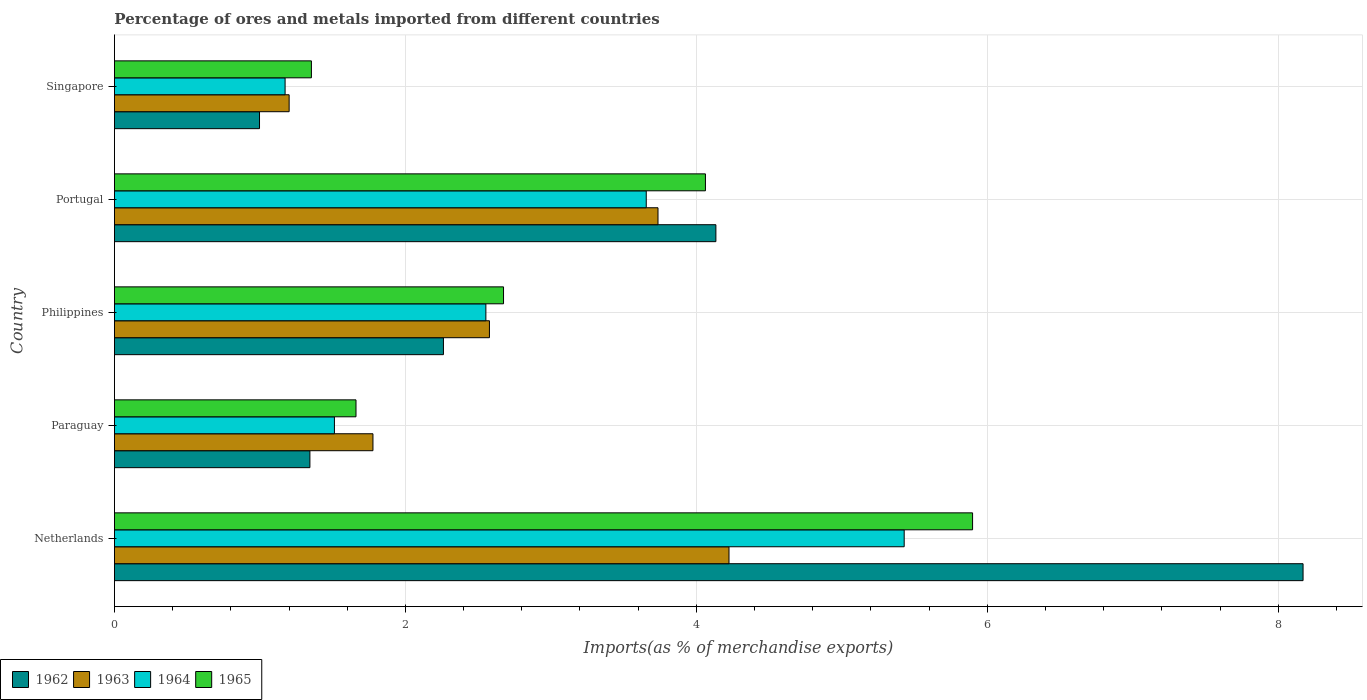How many groups of bars are there?
Your answer should be compact. 5. Are the number of bars per tick equal to the number of legend labels?
Ensure brevity in your answer.  Yes. Are the number of bars on each tick of the Y-axis equal?
Ensure brevity in your answer.  Yes. How many bars are there on the 5th tick from the bottom?
Your answer should be very brief. 4. What is the label of the 2nd group of bars from the top?
Keep it short and to the point. Portugal. In how many cases, is the number of bars for a given country not equal to the number of legend labels?
Provide a succinct answer. 0. What is the percentage of imports to different countries in 1962 in Netherlands?
Give a very brief answer. 8.17. Across all countries, what is the maximum percentage of imports to different countries in 1963?
Your response must be concise. 4.22. Across all countries, what is the minimum percentage of imports to different countries in 1964?
Your answer should be very brief. 1.17. In which country was the percentage of imports to different countries in 1962 maximum?
Offer a very short reply. Netherlands. In which country was the percentage of imports to different countries in 1965 minimum?
Offer a very short reply. Singapore. What is the total percentage of imports to different countries in 1965 in the graph?
Provide a succinct answer. 15.65. What is the difference between the percentage of imports to different countries in 1962 in Paraguay and that in Singapore?
Provide a succinct answer. 0.35. What is the difference between the percentage of imports to different countries in 1962 in Paraguay and the percentage of imports to different countries in 1964 in Philippines?
Ensure brevity in your answer.  -1.21. What is the average percentage of imports to different countries in 1965 per country?
Ensure brevity in your answer.  3.13. What is the difference between the percentage of imports to different countries in 1965 and percentage of imports to different countries in 1964 in Paraguay?
Your response must be concise. 0.15. In how many countries, is the percentage of imports to different countries in 1965 greater than 2.4 %?
Make the answer very short. 3. What is the ratio of the percentage of imports to different countries in 1964 in Paraguay to that in Singapore?
Ensure brevity in your answer.  1.29. Is the percentage of imports to different countries in 1964 in Portugal less than that in Singapore?
Offer a terse response. No. Is the difference between the percentage of imports to different countries in 1965 in Netherlands and Portugal greater than the difference between the percentage of imports to different countries in 1964 in Netherlands and Portugal?
Keep it short and to the point. Yes. What is the difference between the highest and the second highest percentage of imports to different countries in 1963?
Offer a terse response. 0.49. What is the difference between the highest and the lowest percentage of imports to different countries in 1962?
Offer a terse response. 7.17. In how many countries, is the percentage of imports to different countries in 1963 greater than the average percentage of imports to different countries in 1963 taken over all countries?
Keep it short and to the point. 2. Is it the case that in every country, the sum of the percentage of imports to different countries in 1963 and percentage of imports to different countries in 1962 is greater than the sum of percentage of imports to different countries in 1964 and percentage of imports to different countries in 1965?
Give a very brief answer. No. What does the 4th bar from the top in Philippines represents?
Your answer should be very brief. 1962. What does the 3rd bar from the bottom in Portugal represents?
Give a very brief answer. 1964. Are all the bars in the graph horizontal?
Offer a very short reply. Yes. Are the values on the major ticks of X-axis written in scientific E-notation?
Your answer should be very brief. No. How many legend labels are there?
Give a very brief answer. 4. What is the title of the graph?
Your answer should be very brief. Percentage of ores and metals imported from different countries. Does "2014" appear as one of the legend labels in the graph?
Offer a very short reply. No. What is the label or title of the X-axis?
Ensure brevity in your answer.  Imports(as % of merchandise exports). What is the Imports(as % of merchandise exports) in 1962 in Netherlands?
Give a very brief answer. 8.17. What is the Imports(as % of merchandise exports) in 1963 in Netherlands?
Your answer should be compact. 4.22. What is the Imports(as % of merchandise exports) of 1964 in Netherlands?
Provide a short and direct response. 5.43. What is the Imports(as % of merchandise exports) of 1965 in Netherlands?
Provide a short and direct response. 5.9. What is the Imports(as % of merchandise exports) in 1962 in Paraguay?
Give a very brief answer. 1.34. What is the Imports(as % of merchandise exports) of 1963 in Paraguay?
Provide a short and direct response. 1.78. What is the Imports(as % of merchandise exports) of 1964 in Paraguay?
Your response must be concise. 1.51. What is the Imports(as % of merchandise exports) in 1965 in Paraguay?
Provide a short and direct response. 1.66. What is the Imports(as % of merchandise exports) of 1962 in Philippines?
Provide a short and direct response. 2.26. What is the Imports(as % of merchandise exports) of 1963 in Philippines?
Provide a short and direct response. 2.58. What is the Imports(as % of merchandise exports) of 1964 in Philippines?
Offer a terse response. 2.55. What is the Imports(as % of merchandise exports) in 1965 in Philippines?
Make the answer very short. 2.67. What is the Imports(as % of merchandise exports) in 1962 in Portugal?
Provide a short and direct response. 4.13. What is the Imports(as % of merchandise exports) of 1963 in Portugal?
Provide a succinct answer. 3.74. What is the Imports(as % of merchandise exports) of 1964 in Portugal?
Provide a succinct answer. 3.66. What is the Imports(as % of merchandise exports) in 1965 in Portugal?
Your answer should be very brief. 4.06. What is the Imports(as % of merchandise exports) in 1962 in Singapore?
Offer a terse response. 1. What is the Imports(as % of merchandise exports) of 1963 in Singapore?
Offer a terse response. 1.2. What is the Imports(as % of merchandise exports) of 1964 in Singapore?
Ensure brevity in your answer.  1.17. What is the Imports(as % of merchandise exports) in 1965 in Singapore?
Give a very brief answer. 1.35. Across all countries, what is the maximum Imports(as % of merchandise exports) of 1962?
Keep it short and to the point. 8.17. Across all countries, what is the maximum Imports(as % of merchandise exports) of 1963?
Provide a short and direct response. 4.22. Across all countries, what is the maximum Imports(as % of merchandise exports) of 1964?
Your answer should be very brief. 5.43. Across all countries, what is the maximum Imports(as % of merchandise exports) of 1965?
Provide a succinct answer. 5.9. Across all countries, what is the minimum Imports(as % of merchandise exports) in 1962?
Provide a short and direct response. 1. Across all countries, what is the minimum Imports(as % of merchandise exports) in 1963?
Your answer should be very brief. 1.2. Across all countries, what is the minimum Imports(as % of merchandise exports) in 1964?
Your answer should be compact. 1.17. Across all countries, what is the minimum Imports(as % of merchandise exports) of 1965?
Your response must be concise. 1.35. What is the total Imports(as % of merchandise exports) of 1962 in the graph?
Ensure brevity in your answer.  16.91. What is the total Imports(as % of merchandise exports) in 1963 in the graph?
Offer a very short reply. 13.52. What is the total Imports(as % of merchandise exports) of 1964 in the graph?
Ensure brevity in your answer.  14.32. What is the total Imports(as % of merchandise exports) of 1965 in the graph?
Your answer should be compact. 15.65. What is the difference between the Imports(as % of merchandise exports) of 1962 in Netherlands and that in Paraguay?
Your answer should be very brief. 6.83. What is the difference between the Imports(as % of merchandise exports) of 1963 in Netherlands and that in Paraguay?
Keep it short and to the point. 2.45. What is the difference between the Imports(as % of merchandise exports) in 1964 in Netherlands and that in Paraguay?
Your response must be concise. 3.92. What is the difference between the Imports(as % of merchandise exports) in 1965 in Netherlands and that in Paraguay?
Offer a very short reply. 4.24. What is the difference between the Imports(as % of merchandise exports) of 1962 in Netherlands and that in Philippines?
Ensure brevity in your answer.  5.91. What is the difference between the Imports(as % of merchandise exports) in 1963 in Netherlands and that in Philippines?
Give a very brief answer. 1.65. What is the difference between the Imports(as % of merchandise exports) of 1964 in Netherlands and that in Philippines?
Provide a short and direct response. 2.88. What is the difference between the Imports(as % of merchandise exports) of 1965 in Netherlands and that in Philippines?
Keep it short and to the point. 3.22. What is the difference between the Imports(as % of merchandise exports) of 1962 in Netherlands and that in Portugal?
Offer a very short reply. 4.04. What is the difference between the Imports(as % of merchandise exports) of 1963 in Netherlands and that in Portugal?
Ensure brevity in your answer.  0.49. What is the difference between the Imports(as % of merchandise exports) of 1964 in Netherlands and that in Portugal?
Provide a succinct answer. 1.77. What is the difference between the Imports(as % of merchandise exports) of 1965 in Netherlands and that in Portugal?
Keep it short and to the point. 1.84. What is the difference between the Imports(as % of merchandise exports) in 1962 in Netherlands and that in Singapore?
Your response must be concise. 7.17. What is the difference between the Imports(as % of merchandise exports) in 1963 in Netherlands and that in Singapore?
Ensure brevity in your answer.  3.02. What is the difference between the Imports(as % of merchandise exports) in 1964 in Netherlands and that in Singapore?
Offer a very short reply. 4.26. What is the difference between the Imports(as % of merchandise exports) of 1965 in Netherlands and that in Singapore?
Your answer should be very brief. 4.55. What is the difference between the Imports(as % of merchandise exports) in 1962 in Paraguay and that in Philippines?
Provide a short and direct response. -0.92. What is the difference between the Imports(as % of merchandise exports) in 1963 in Paraguay and that in Philippines?
Your answer should be very brief. -0.8. What is the difference between the Imports(as % of merchandise exports) of 1964 in Paraguay and that in Philippines?
Give a very brief answer. -1.04. What is the difference between the Imports(as % of merchandise exports) in 1965 in Paraguay and that in Philippines?
Offer a terse response. -1.01. What is the difference between the Imports(as % of merchandise exports) in 1962 in Paraguay and that in Portugal?
Keep it short and to the point. -2.79. What is the difference between the Imports(as % of merchandise exports) of 1963 in Paraguay and that in Portugal?
Keep it short and to the point. -1.96. What is the difference between the Imports(as % of merchandise exports) of 1964 in Paraguay and that in Portugal?
Provide a short and direct response. -2.14. What is the difference between the Imports(as % of merchandise exports) of 1965 in Paraguay and that in Portugal?
Provide a succinct answer. -2.4. What is the difference between the Imports(as % of merchandise exports) of 1962 in Paraguay and that in Singapore?
Your answer should be compact. 0.35. What is the difference between the Imports(as % of merchandise exports) in 1963 in Paraguay and that in Singapore?
Your answer should be compact. 0.58. What is the difference between the Imports(as % of merchandise exports) of 1964 in Paraguay and that in Singapore?
Your response must be concise. 0.34. What is the difference between the Imports(as % of merchandise exports) in 1965 in Paraguay and that in Singapore?
Provide a succinct answer. 0.31. What is the difference between the Imports(as % of merchandise exports) of 1962 in Philippines and that in Portugal?
Keep it short and to the point. -1.87. What is the difference between the Imports(as % of merchandise exports) in 1963 in Philippines and that in Portugal?
Provide a short and direct response. -1.16. What is the difference between the Imports(as % of merchandise exports) in 1964 in Philippines and that in Portugal?
Make the answer very short. -1.1. What is the difference between the Imports(as % of merchandise exports) of 1965 in Philippines and that in Portugal?
Make the answer very short. -1.39. What is the difference between the Imports(as % of merchandise exports) of 1962 in Philippines and that in Singapore?
Keep it short and to the point. 1.26. What is the difference between the Imports(as % of merchandise exports) of 1963 in Philippines and that in Singapore?
Offer a very short reply. 1.38. What is the difference between the Imports(as % of merchandise exports) in 1964 in Philippines and that in Singapore?
Your answer should be compact. 1.38. What is the difference between the Imports(as % of merchandise exports) in 1965 in Philippines and that in Singapore?
Your answer should be very brief. 1.32. What is the difference between the Imports(as % of merchandise exports) of 1962 in Portugal and that in Singapore?
Make the answer very short. 3.14. What is the difference between the Imports(as % of merchandise exports) in 1963 in Portugal and that in Singapore?
Give a very brief answer. 2.54. What is the difference between the Imports(as % of merchandise exports) in 1964 in Portugal and that in Singapore?
Your answer should be very brief. 2.48. What is the difference between the Imports(as % of merchandise exports) of 1965 in Portugal and that in Singapore?
Your answer should be very brief. 2.71. What is the difference between the Imports(as % of merchandise exports) of 1962 in Netherlands and the Imports(as % of merchandise exports) of 1963 in Paraguay?
Ensure brevity in your answer.  6.39. What is the difference between the Imports(as % of merchandise exports) in 1962 in Netherlands and the Imports(as % of merchandise exports) in 1964 in Paraguay?
Offer a very short reply. 6.66. What is the difference between the Imports(as % of merchandise exports) of 1962 in Netherlands and the Imports(as % of merchandise exports) of 1965 in Paraguay?
Give a very brief answer. 6.51. What is the difference between the Imports(as % of merchandise exports) of 1963 in Netherlands and the Imports(as % of merchandise exports) of 1964 in Paraguay?
Ensure brevity in your answer.  2.71. What is the difference between the Imports(as % of merchandise exports) in 1963 in Netherlands and the Imports(as % of merchandise exports) in 1965 in Paraguay?
Offer a terse response. 2.56. What is the difference between the Imports(as % of merchandise exports) of 1964 in Netherlands and the Imports(as % of merchandise exports) of 1965 in Paraguay?
Offer a very short reply. 3.77. What is the difference between the Imports(as % of merchandise exports) in 1962 in Netherlands and the Imports(as % of merchandise exports) in 1963 in Philippines?
Ensure brevity in your answer.  5.59. What is the difference between the Imports(as % of merchandise exports) in 1962 in Netherlands and the Imports(as % of merchandise exports) in 1964 in Philippines?
Offer a very short reply. 5.62. What is the difference between the Imports(as % of merchandise exports) in 1962 in Netherlands and the Imports(as % of merchandise exports) in 1965 in Philippines?
Offer a very short reply. 5.5. What is the difference between the Imports(as % of merchandise exports) in 1963 in Netherlands and the Imports(as % of merchandise exports) in 1964 in Philippines?
Offer a very short reply. 1.67. What is the difference between the Imports(as % of merchandise exports) of 1963 in Netherlands and the Imports(as % of merchandise exports) of 1965 in Philippines?
Offer a very short reply. 1.55. What is the difference between the Imports(as % of merchandise exports) of 1964 in Netherlands and the Imports(as % of merchandise exports) of 1965 in Philippines?
Your answer should be compact. 2.75. What is the difference between the Imports(as % of merchandise exports) of 1962 in Netherlands and the Imports(as % of merchandise exports) of 1963 in Portugal?
Your answer should be compact. 4.43. What is the difference between the Imports(as % of merchandise exports) of 1962 in Netherlands and the Imports(as % of merchandise exports) of 1964 in Portugal?
Ensure brevity in your answer.  4.51. What is the difference between the Imports(as % of merchandise exports) in 1962 in Netherlands and the Imports(as % of merchandise exports) in 1965 in Portugal?
Your answer should be very brief. 4.11. What is the difference between the Imports(as % of merchandise exports) of 1963 in Netherlands and the Imports(as % of merchandise exports) of 1964 in Portugal?
Provide a short and direct response. 0.57. What is the difference between the Imports(as % of merchandise exports) in 1963 in Netherlands and the Imports(as % of merchandise exports) in 1965 in Portugal?
Provide a succinct answer. 0.16. What is the difference between the Imports(as % of merchandise exports) of 1964 in Netherlands and the Imports(as % of merchandise exports) of 1965 in Portugal?
Your response must be concise. 1.37. What is the difference between the Imports(as % of merchandise exports) in 1962 in Netherlands and the Imports(as % of merchandise exports) in 1963 in Singapore?
Ensure brevity in your answer.  6.97. What is the difference between the Imports(as % of merchandise exports) of 1962 in Netherlands and the Imports(as % of merchandise exports) of 1964 in Singapore?
Your answer should be very brief. 7. What is the difference between the Imports(as % of merchandise exports) of 1962 in Netherlands and the Imports(as % of merchandise exports) of 1965 in Singapore?
Your answer should be compact. 6.82. What is the difference between the Imports(as % of merchandise exports) in 1963 in Netherlands and the Imports(as % of merchandise exports) in 1964 in Singapore?
Your answer should be compact. 3.05. What is the difference between the Imports(as % of merchandise exports) in 1963 in Netherlands and the Imports(as % of merchandise exports) in 1965 in Singapore?
Provide a short and direct response. 2.87. What is the difference between the Imports(as % of merchandise exports) of 1964 in Netherlands and the Imports(as % of merchandise exports) of 1965 in Singapore?
Your response must be concise. 4.07. What is the difference between the Imports(as % of merchandise exports) in 1962 in Paraguay and the Imports(as % of merchandise exports) in 1963 in Philippines?
Offer a very short reply. -1.23. What is the difference between the Imports(as % of merchandise exports) of 1962 in Paraguay and the Imports(as % of merchandise exports) of 1964 in Philippines?
Offer a terse response. -1.21. What is the difference between the Imports(as % of merchandise exports) in 1962 in Paraguay and the Imports(as % of merchandise exports) in 1965 in Philippines?
Offer a very short reply. -1.33. What is the difference between the Imports(as % of merchandise exports) in 1963 in Paraguay and the Imports(as % of merchandise exports) in 1964 in Philippines?
Offer a terse response. -0.78. What is the difference between the Imports(as % of merchandise exports) in 1963 in Paraguay and the Imports(as % of merchandise exports) in 1965 in Philippines?
Your answer should be compact. -0.9. What is the difference between the Imports(as % of merchandise exports) in 1964 in Paraguay and the Imports(as % of merchandise exports) in 1965 in Philippines?
Keep it short and to the point. -1.16. What is the difference between the Imports(as % of merchandise exports) in 1962 in Paraguay and the Imports(as % of merchandise exports) in 1963 in Portugal?
Keep it short and to the point. -2.39. What is the difference between the Imports(as % of merchandise exports) of 1962 in Paraguay and the Imports(as % of merchandise exports) of 1964 in Portugal?
Give a very brief answer. -2.31. What is the difference between the Imports(as % of merchandise exports) of 1962 in Paraguay and the Imports(as % of merchandise exports) of 1965 in Portugal?
Offer a terse response. -2.72. What is the difference between the Imports(as % of merchandise exports) in 1963 in Paraguay and the Imports(as % of merchandise exports) in 1964 in Portugal?
Make the answer very short. -1.88. What is the difference between the Imports(as % of merchandise exports) in 1963 in Paraguay and the Imports(as % of merchandise exports) in 1965 in Portugal?
Your answer should be very brief. -2.29. What is the difference between the Imports(as % of merchandise exports) in 1964 in Paraguay and the Imports(as % of merchandise exports) in 1965 in Portugal?
Your answer should be very brief. -2.55. What is the difference between the Imports(as % of merchandise exports) of 1962 in Paraguay and the Imports(as % of merchandise exports) of 1963 in Singapore?
Offer a very short reply. 0.14. What is the difference between the Imports(as % of merchandise exports) in 1962 in Paraguay and the Imports(as % of merchandise exports) in 1964 in Singapore?
Give a very brief answer. 0.17. What is the difference between the Imports(as % of merchandise exports) of 1962 in Paraguay and the Imports(as % of merchandise exports) of 1965 in Singapore?
Your answer should be very brief. -0.01. What is the difference between the Imports(as % of merchandise exports) in 1963 in Paraguay and the Imports(as % of merchandise exports) in 1964 in Singapore?
Give a very brief answer. 0.6. What is the difference between the Imports(as % of merchandise exports) in 1963 in Paraguay and the Imports(as % of merchandise exports) in 1965 in Singapore?
Your answer should be compact. 0.42. What is the difference between the Imports(as % of merchandise exports) in 1964 in Paraguay and the Imports(as % of merchandise exports) in 1965 in Singapore?
Ensure brevity in your answer.  0.16. What is the difference between the Imports(as % of merchandise exports) of 1962 in Philippines and the Imports(as % of merchandise exports) of 1963 in Portugal?
Offer a very short reply. -1.47. What is the difference between the Imports(as % of merchandise exports) in 1962 in Philippines and the Imports(as % of merchandise exports) in 1964 in Portugal?
Ensure brevity in your answer.  -1.39. What is the difference between the Imports(as % of merchandise exports) of 1962 in Philippines and the Imports(as % of merchandise exports) of 1965 in Portugal?
Give a very brief answer. -1.8. What is the difference between the Imports(as % of merchandise exports) of 1963 in Philippines and the Imports(as % of merchandise exports) of 1964 in Portugal?
Keep it short and to the point. -1.08. What is the difference between the Imports(as % of merchandise exports) of 1963 in Philippines and the Imports(as % of merchandise exports) of 1965 in Portugal?
Provide a succinct answer. -1.48. What is the difference between the Imports(as % of merchandise exports) of 1964 in Philippines and the Imports(as % of merchandise exports) of 1965 in Portugal?
Give a very brief answer. -1.51. What is the difference between the Imports(as % of merchandise exports) of 1962 in Philippines and the Imports(as % of merchandise exports) of 1963 in Singapore?
Offer a terse response. 1.06. What is the difference between the Imports(as % of merchandise exports) of 1962 in Philippines and the Imports(as % of merchandise exports) of 1964 in Singapore?
Keep it short and to the point. 1.09. What is the difference between the Imports(as % of merchandise exports) of 1962 in Philippines and the Imports(as % of merchandise exports) of 1965 in Singapore?
Ensure brevity in your answer.  0.91. What is the difference between the Imports(as % of merchandise exports) in 1963 in Philippines and the Imports(as % of merchandise exports) in 1964 in Singapore?
Your answer should be compact. 1.4. What is the difference between the Imports(as % of merchandise exports) in 1963 in Philippines and the Imports(as % of merchandise exports) in 1965 in Singapore?
Provide a succinct answer. 1.22. What is the difference between the Imports(as % of merchandise exports) in 1964 in Philippines and the Imports(as % of merchandise exports) in 1965 in Singapore?
Your response must be concise. 1.2. What is the difference between the Imports(as % of merchandise exports) in 1962 in Portugal and the Imports(as % of merchandise exports) in 1963 in Singapore?
Provide a short and direct response. 2.93. What is the difference between the Imports(as % of merchandise exports) in 1962 in Portugal and the Imports(as % of merchandise exports) in 1964 in Singapore?
Provide a succinct answer. 2.96. What is the difference between the Imports(as % of merchandise exports) of 1962 in Portugal and the Imports(as % of merchandise exports) of 1965 in Singapore?
Your answer should be compact. 2.78. What is the difference between the Imports(as % of merchandise exports) of 1963 in Portugal and the Imports(as % of merchandise exports) of 1964 in Singapore?
Provide a short and direct response. 2.56. What is the difference between the Imports(as % of merchandise exports) in 1963 in Portugal and the Imports(as % of merchandise exports) in 1965 in Singapore?
Offer a very short reply. 2.38. What is the difference between the Imports(as % of merchandise exports) of 1964 in Portugal and the Imports(as % of merchandise exports) of 1965 in Singapore?
Give a very brief answer. 2.3. What is the average Imports(as % of merchandise exports) of 1962 per country?
Offer a terse response. 3.38. What is the average Imports(as % of merchandise exports) in 1963 per country?
Your response must be concise. 2.7. What is the average Imports(as % of merchandise exports) in 1964 per country?
Offer a terse response. 2.86. What is the average Imports(as % of merchandise exports) in 1965 per country?
Keep it short and to the point. 3.13. What is the difference between the Imports(as % of merchandise exports) of 1962 and Imports(as % of merchandise exports) of 1963 in Netherlands?
Offer a terse response. 3.95. What is the difference between the Imports(as % of merchandise exports) of 1962 and Imports(as % of merchandise exports) of 1964 in Netherlands?
Your answer should be very brief. 2.74. What is the difference between the Imports(as % of merchandise exports) of 1962 and Imports(as % of merchandise exports) of 1965 in Netherlands?
Make the answer very short. 2.27. What is the difference between the Imports(as % of merchandise exports) of 1963 and Imports(as % of merchandise exports) of 1964 in Netherlands?
Your answer should be compact. -1.2. What is the difference between the Imports(as % of merchandise exports) in 1963 and Imports(as % of merchandise exports) in 1965 in Netherlands?
Give a very brief answer. -1.67. What is the difference between the Imports(as % of merchandise exports) in 1964 and Imports(as % of merchandise exports) in 1965 in Netherlands?
Ensure brevity in your answer.  -0.47. What is the difference between the Imports(as % of merchandise exports) in 1962 and Imports(as % of merchandise exports) in 1963 in Paraguay?
Offer a very short reply. -0.43. What is the difference between the Imports(as % of merchandise exports) in 1962 and Imports(as % of merchandise exports) in 1964 in Paraguay?
Provide a short and direct response. -0.17. What is the difference between the Imports(as % of merchandise exports) in 1962 and Imports(as % of merchandise exports) in 1965 in Paraguay?
Your answer should be compact. -0.32. What is the difference between the Imports(as % of merchandise exports) of 1963 and Imports(as % of merchandise exports) of 1964 in Paraguay?
Ensure brevity in your answer.  0.26. What is the difference between the Imports(as % of merchandise exports) of 1963 and Imports(as % of merchandise exports) of 1965 in Paraguay?
Provide a short and direct response. 0.12. What is the difference between the Imports(as % of merchandise exports) in 1964 and Imports(as % of merchandise exports) in 1965 in Paraguay?
Your answer should be compact. -0.15. What is the difference between the Imports(as % of merchandise exports) in 1962 and Imports(as % of merchandise exports) in 1963 in Philippines?
Keep it short and to the point. -0.32. What is the difference between the Imports(as % of merchandise exports) in 1962 and Imports(as % of merchandise exports) in 1964 in Philippines?
Provide a short and direct response. -0.29. What is the difference between the Imports(as % of merchandise exports) in 1962 and Imports(as % of merchandise exports) in 1965 in Philippines?
Your answer should be very brief. -0.41. What is the difference between the Imports(as % of merchandise exports) of 1963 and Imports(as % of merchandise exports) of 1964 in Philippines?
Ensure brevity in your answer.  0.02. What is the difference between the Imports(as % of merchandise exports) of 1963 and Imports(as % of merchandise exports) of 1965 in Philippines?
Offer a very short reply. -0.1. What is the difference between the Imports(as % of merchandise exports) of 1964 and Imports(as % of merchandise exports) of 1965 in Philippines?
Make the answer very short. -0.12. What is the difference between the Imports(as % of merchandise exports) in 1962 and Imports(as % of merchandise exports) in 1963 in Portugal?
Your answer should be compact. 0.4. What is the difference between the Imports(as % of merchandise exports) in 1962 and Imports(as % of merchandise exports) in 1964 in Portugal?
Provide a short and direct response. 0.48. What is the difference between the Imports(as % of merchandise exports) of 1962 and Imports(as % of merchandise exports) of 1965 in Portugal?
Ensure brevity in your answer.  0.07. What is the difference between the Imports(as % of merchandise exports) in 1963 and Imports(as % of merchandise exports) in 1964 in Portugal?
Provide a succinct answer. 0.08. What is the difference between the Imports(as % of merchandise exports) in 1963 and Imports(as % of merchandise exports) in 1965 in Portugal?
Your answer should be very brief. -0.33. What is the difference between the Imports(as % of merchandise exports) of 1964 and Imports(as % of merchandise exports) of 1965 in Portugal?
Your response must be concise. -0.41. What is the difference between the Imports(as % of merchandise exports) of 1962 and Imports(as % of merchandise exports) of 1963 in Singapore?
Keep it short and to the point. -0.2. What is the difference between the Imports(as % of merchandise exports) of 1962 and Imports(as % of merchandise exports) of 1964 in Singapore?
Your answer should be very brief. -0.18. What is the difference between the Imports(as % of merchandise exports) of 1962 and Imports(as % of merchandise exports) of 1965 in Singapore?
Provide a succinct answer. -0.36. What is the difference between the Imports(as % of merchandise exports) in 1963 and Imports(as % of merchandise exports) in 1964 in Singapore?
Make the answer very short. 0.03. What is the difference between the Imports(as % of merchandise exports) of 1963 and Imports(as % of merchandise exports) of 1965 in Singapore?
Your answer should be very brief. -0.15. What is the difference between the Imports(as % of merchandise exports) of 1964 and Imports(as % of merchandise exports) of 1965 in Singapore?
Ensure brevity in your answer.  -0.18. What is the ratio of the Imports(as % of merchandise exports) of 1962 in Netherlands to that in Paraguay?
Your response must be concise. 6.08. What is the ratio of the Imports(as % of merchandise exports) in 1963 in Netherlands to that in Paraguay?
Provide a short and direct response. 2.38. What is the ratio of the Imports(as % of merchandise exports) of 1964 in Netherlands to that in Paraguay?
Provide a short and direct response. 3.59. What is the ratio of the Imports(as % of merchandise exports) in 1965 in Netherlands to that in Paraguay?
Your answer should be very brief. 3.55. What is the ratio of the Imports(as % of merchandise exports) in 1962 in Netherlands to that in Philippines?
Your answer should be compact. 3.61. What is the ratio of the Imports(as % of merchandise exports) of 1963 in Netherlands to that in Philippines?
Your answer should be very brief. 1.64. What is the ratio of the Imports(as % of merchandise exports) of 1964 in Netherlands to that in Philippines?
Your answer should be compact. 2.13. What is the ratio of the Imports(as % of merchandise exports) of 1965 in Netherlands to that in Philippines?
Provide a short and direct response. 2.21. What is the ratio of the Imports(as % of merchandise exports) of 1962 in Netherlands to that in Portugal?
Offer a terse response. 1.98. What is the ratio of the Imports(as % of merchandise exports) in 1963 in Netherlands to that in Portugal?
Keep it short and to the point. 1.13. What is the ratio of the Imports(as % of merchandise exports) of 1964 in Netherlands to that in Portugal?
Your response must be concise. 1.49. What is the ratio of the Imports(as % of merchandise exports) of 1965 in Netherlands to that in Portugal?
Provide a short and direct response. 1.45. What is the ratio of the Imports(as % of merchandise exports) in 1962 in Netherlands to that in Singapore?
Offer a terse response. 8.19. What is the ratio of the Imports(as % of merchandise exports) of 1963 in Netherlands to that in Singapore?
Provide a succinct answer. 3.52. What is the ratio of the Imports(as % of merchandise exports) in 1964 in Netherlands to that in Singapore?
Offer a very short reply. 4.63. What is the ratio of the Imports(as % of merchandise exports) of 1965 in Netherlands to that in Singapore?
Offer a terse response. 4.36. What is the ratio of the Imports(as % of merchandise exports) of 1962 in Paraguay to that in Philippines?
Offer a terse response. 0.59. What is the ratio of the Imports(as % of merchandise exports) of 1963 in Paraguay to that in Philippines?
Ensure brevity in your answer.  0.69. What is the ratio of the Imports(as % of merchandise exports) of 1964 in Paraguay to that in Philippines?
Offer a terse response. 0.59. What is the ratio of the Imports(as % of merchandise exports) in 1965 in Paraguay to that in Philippines?
Your answer should be compact. 0.62. What is the ratio of the Imports(as % of merchandise exports) of 1962 in Paraguay to that in Portugal?
Ensure brevity in your answer.  0.33. What is the ratio of the Imports(as % of merchandise exports) in 1963 in Paraguay to that in Portugal?
Give a very brief answer. 0.48. What is the ratio of the Imports(as % of merchandise exports) of 1964 in Paraguay to that in Portugal?
Offer a very short reply. 0.41. What is the ratio of the Imports(as % of merchandise exports) of 1965 in Paraguay to that in Portugal?
Offer a very short reply. 0.41. What is the ratio of the Imports(as % of merchandise exports) of 1962 in Paraguay to that in Singapore?
Provide a succinct answer. 1.35. What is the ratio of the Imports(as % of merchandise exports) of 1963 in Paraguay to that in Singapore?
Offer a terse response. 1.48. What is the ratio of the Imports(as % of merchandise exports) of 1964 in Paraguay to that in Singapore?
Your response must be concise. 1.29. What is the ratio of the Imports(as % of merchandise exports) of 1965 in Paraguay to that in Singapore?
Ensure brevity in your answer.  1.23. What is the ratio of the Imports(as % of merchandise exports) in 1962 in Philippines to that in Portugal?
Ensure brevity in your answer.  0.55. What is the ratio of the Imports(as % of merchandise exports) of 1963 in Philippines to that in Portugal?
Make the answer very short. 0.69. What is the ratio of the Imports(as % of merchandise exports) in 1964 in Philippines to that in Portugal?
Your answer should be very brief. 0.7. What is the ratio of the Imports(as % of merchandise exports) in 1965 in Philippines to that in Portugal?
Ensure brevity in your answer.  0.66. What is the ratio of the Imports(as % of merchandise exports) of 1962 in Philippines to that in Singapore?
Your answer should be very brief. 2.27. What is the ratio of the Imports(as % of merchandise exports) in 1963 in Philippines to that in Singapore?
Offer a very short reply. 2.15. What is the ratio of the Imports(as % of merchandise exports) of 1964 in Philippines to that in Singapore?
Ensure brevity in your answer.  2.18. What is the ratio of the Imports(as % of merchandise exports) of 1965 in Philippines to that in Singapore?
Provide a short and direct response. 1.98. What is the ratio of the Imports(as % of merchandise exports) in 1962 in Portugal to that in Singapore?
Ensure brevity in your answer.  4.15. What is the ratio of the Imports(as % of merchandise exports) in 1963 in Portugal to that in Singapore?
Provide a succinct answer. 3.11. What is the ratio of the Imports(as % of merchandise exports) of 1964 in Portugal to that in Singapore?
Offer a very short reply. 3.12. What is the ratio of the Imports(as % of merchandise exports) of 1965 in Portugal to that in Singapore?
Give a very brief answer. 3. What is the difference between the highest and the second highest Imports(as % of merchandise exports) in 1962?
Your answer should be very brief. 4.04. What is the difference between the highest and the second highest Imports(as % of merchandise exports) in 1963?
Give a very brief answer. 0.49. What is the difference between the highest and the second highest Imports(as % of merchandise exports) in 1964?
Your answer should be very brief. 1.77. What is the difference between the highest and the second highest Imports(as % of merchandise exports) in 1965?
Your answer should be compact. 1.84. What is the difference between the highest and the lowest Imports(as % of merchandise exports) of 1962?
Your response must be concise. 7.17. What is the difference between the highest and the lowest Imports(as % of merchandise exports) in 1963?
Give a very brief answer. 3.02. What is the difference between the highest and the lowest Imports(as % of merchandise exports) of 1964?
Your answer should be very brief. 4.26. What is the difference between the highest and the lowest Imports(as % of merchandise exports) in 1965?
Offer a terse response. 4.55. 